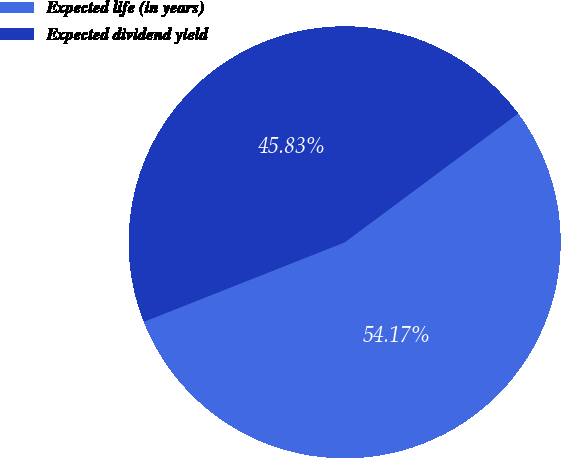Convert chart. <chart><loc_0><loc_0><loc_500><loc_500><pie_chart><fcel>Expected life (in years)<fcel>Expected dividend yield<nl><fcel>54.17%<fcel>45.83%<nl></chart> 